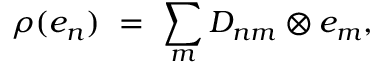<formula> <loc_0><loc_0><loc_500><loc_500>\rho ( e _ { n } ) = \sum _ { m } D _ { n m } \otimes e _ { m } ,</formula> 